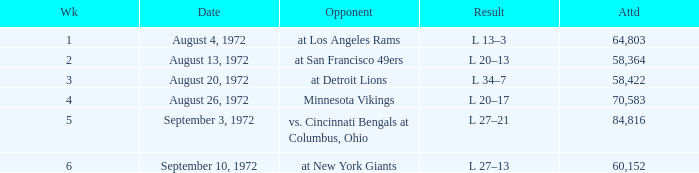What is the date of week 4? August 26, 1972. 